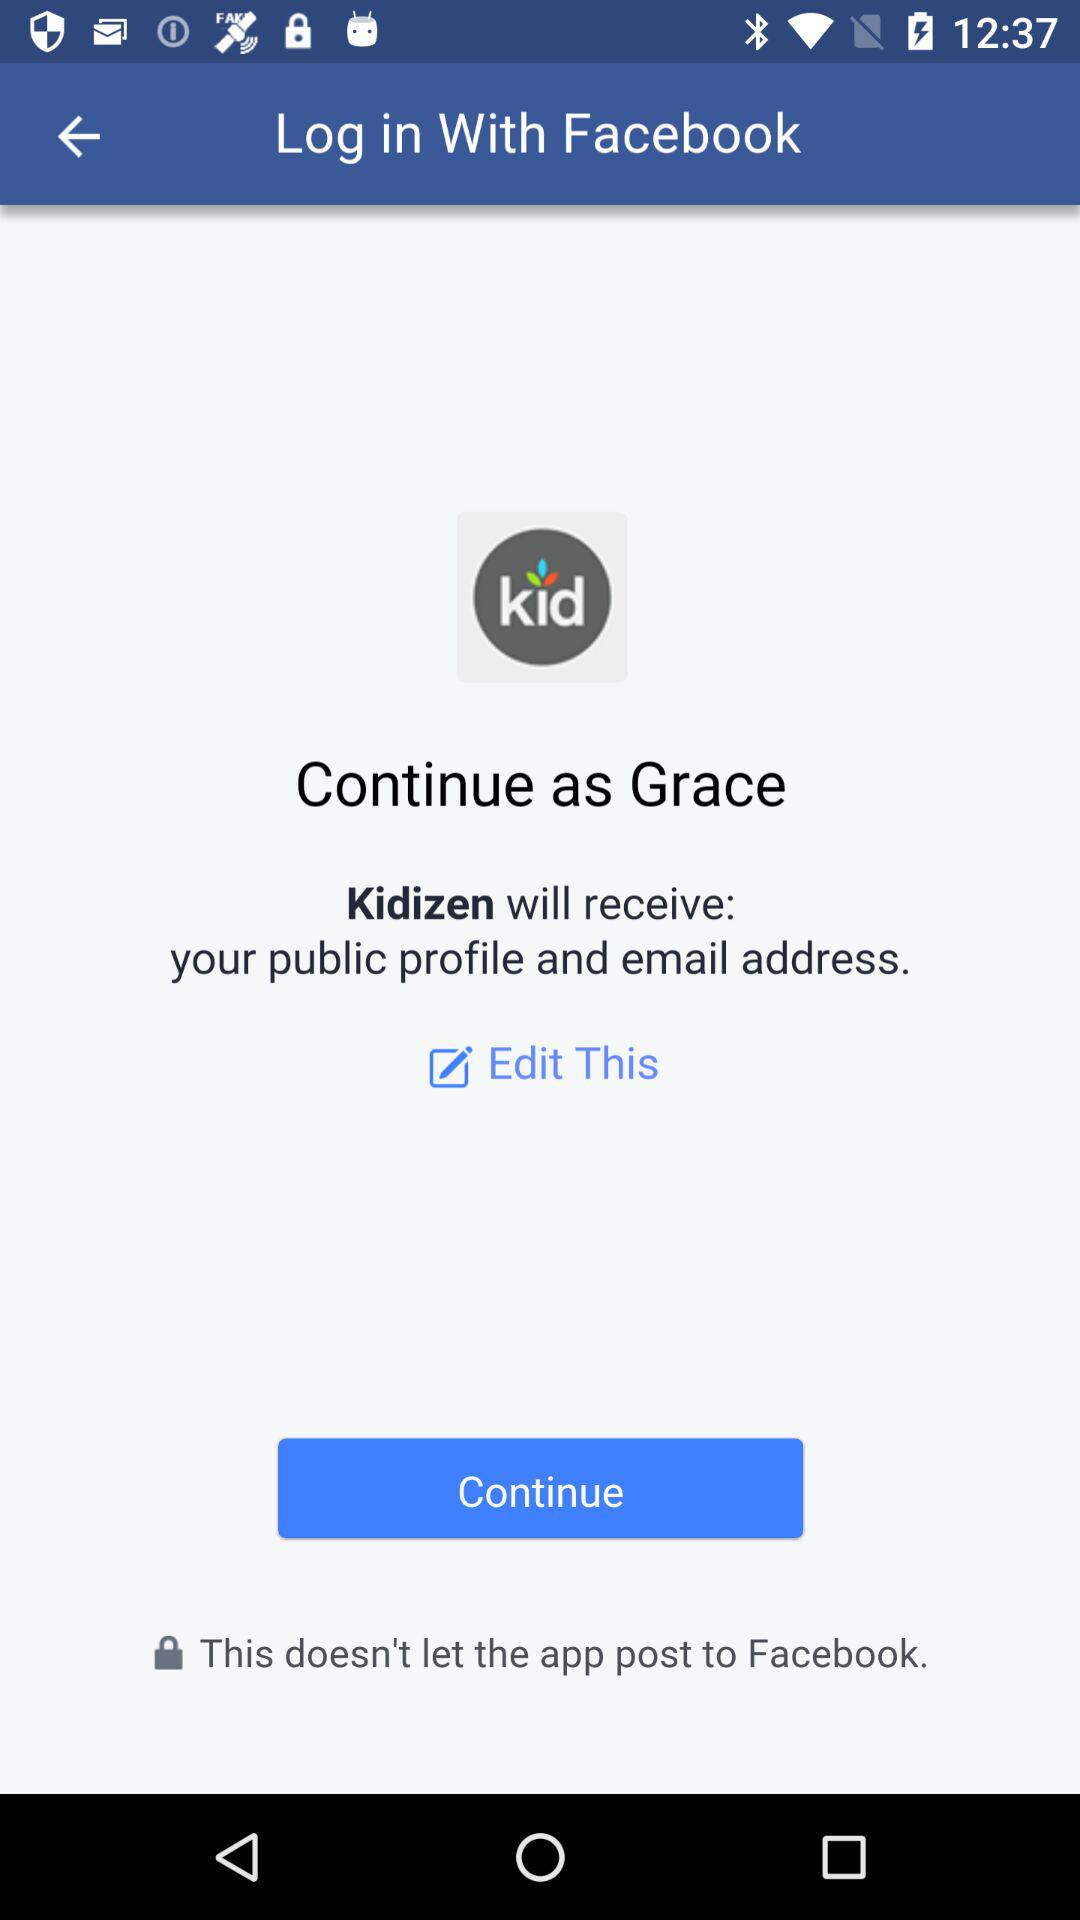What is the application name? The applications' names are "Facebook" and "Kidizen". 